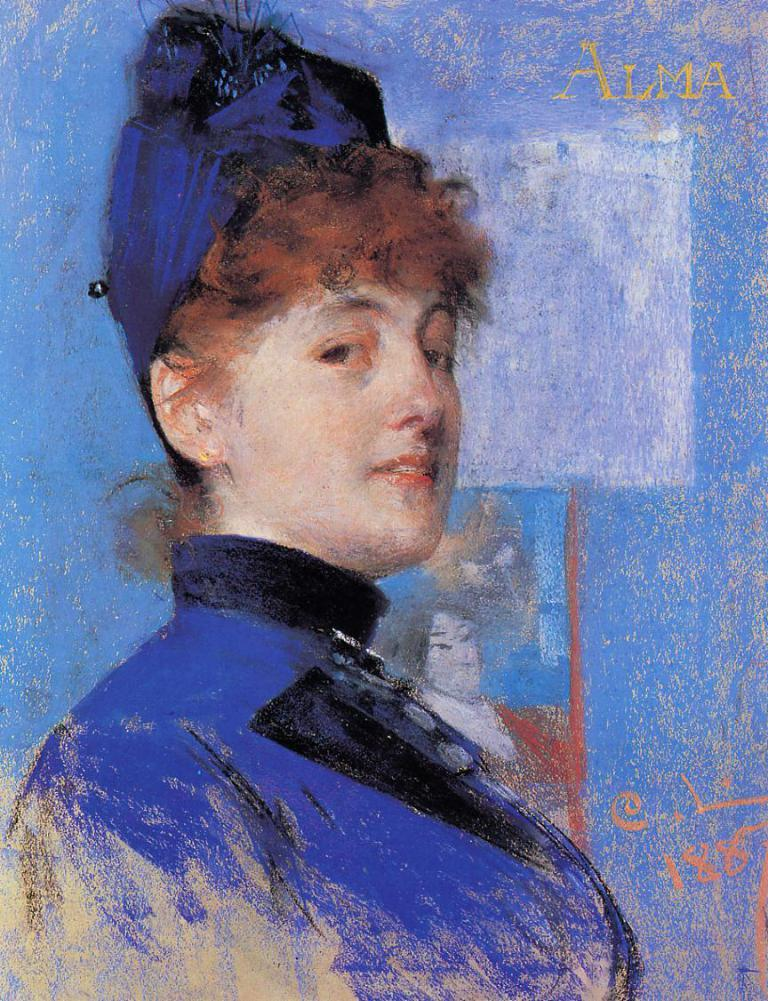What is depicted in the painting in the image? There is a painting of a woman in the image. What else can be seen in the image besides the painting? There is something written on the image. What type of straw is being used to stir the honey in the image? There is no straw or honey present in the image; it only features a painting of a woman and some writing. 